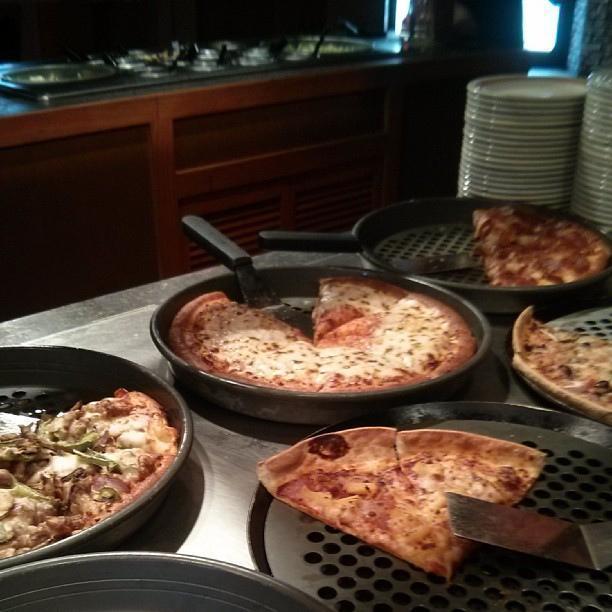How many slices of pizza are left on the closest pan?
Give a very brief answer. 2. How many pizzas are there?
Give a very brief answer. 6. How many dogs playing?
Give a very brief answer. 0. 